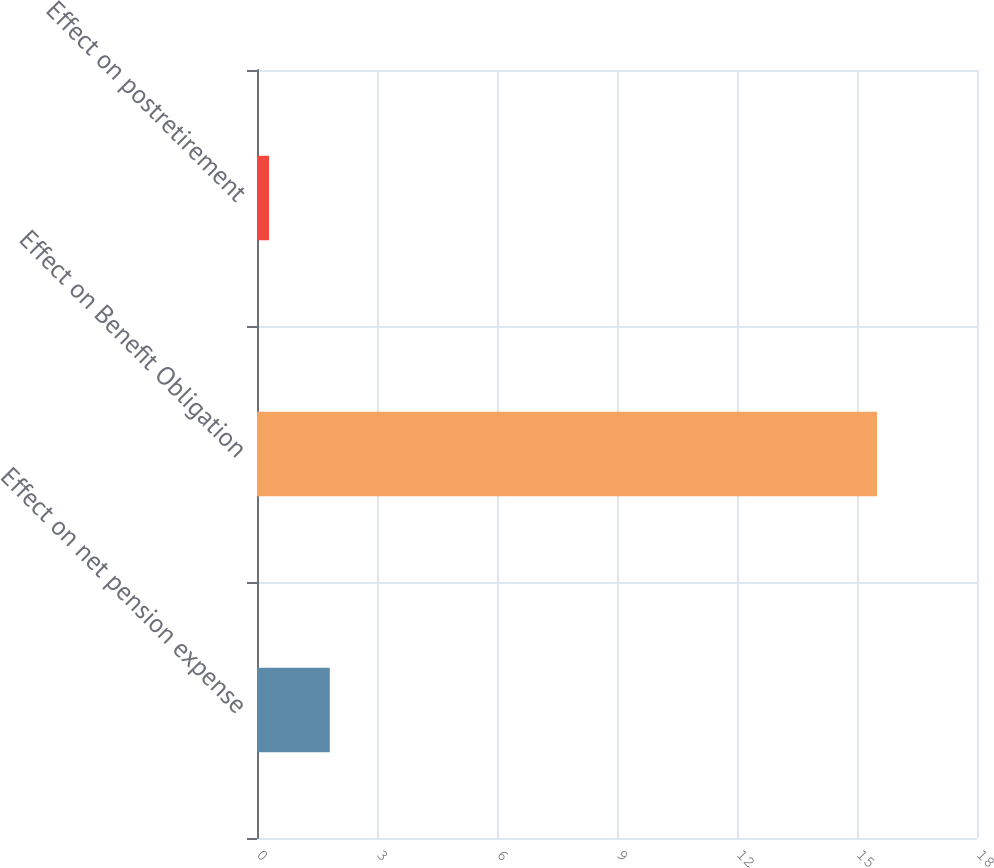<chart> <loc_0><loc_0><loc_500><loc_500><bar_chart><fcel>Effect on net pension expense<fcel>Effect on Benefit Obligation<fcel>Effect on postretirement<nl><fcel>1.82<fcel>15.5<fcel>0.3<nl></chart> 